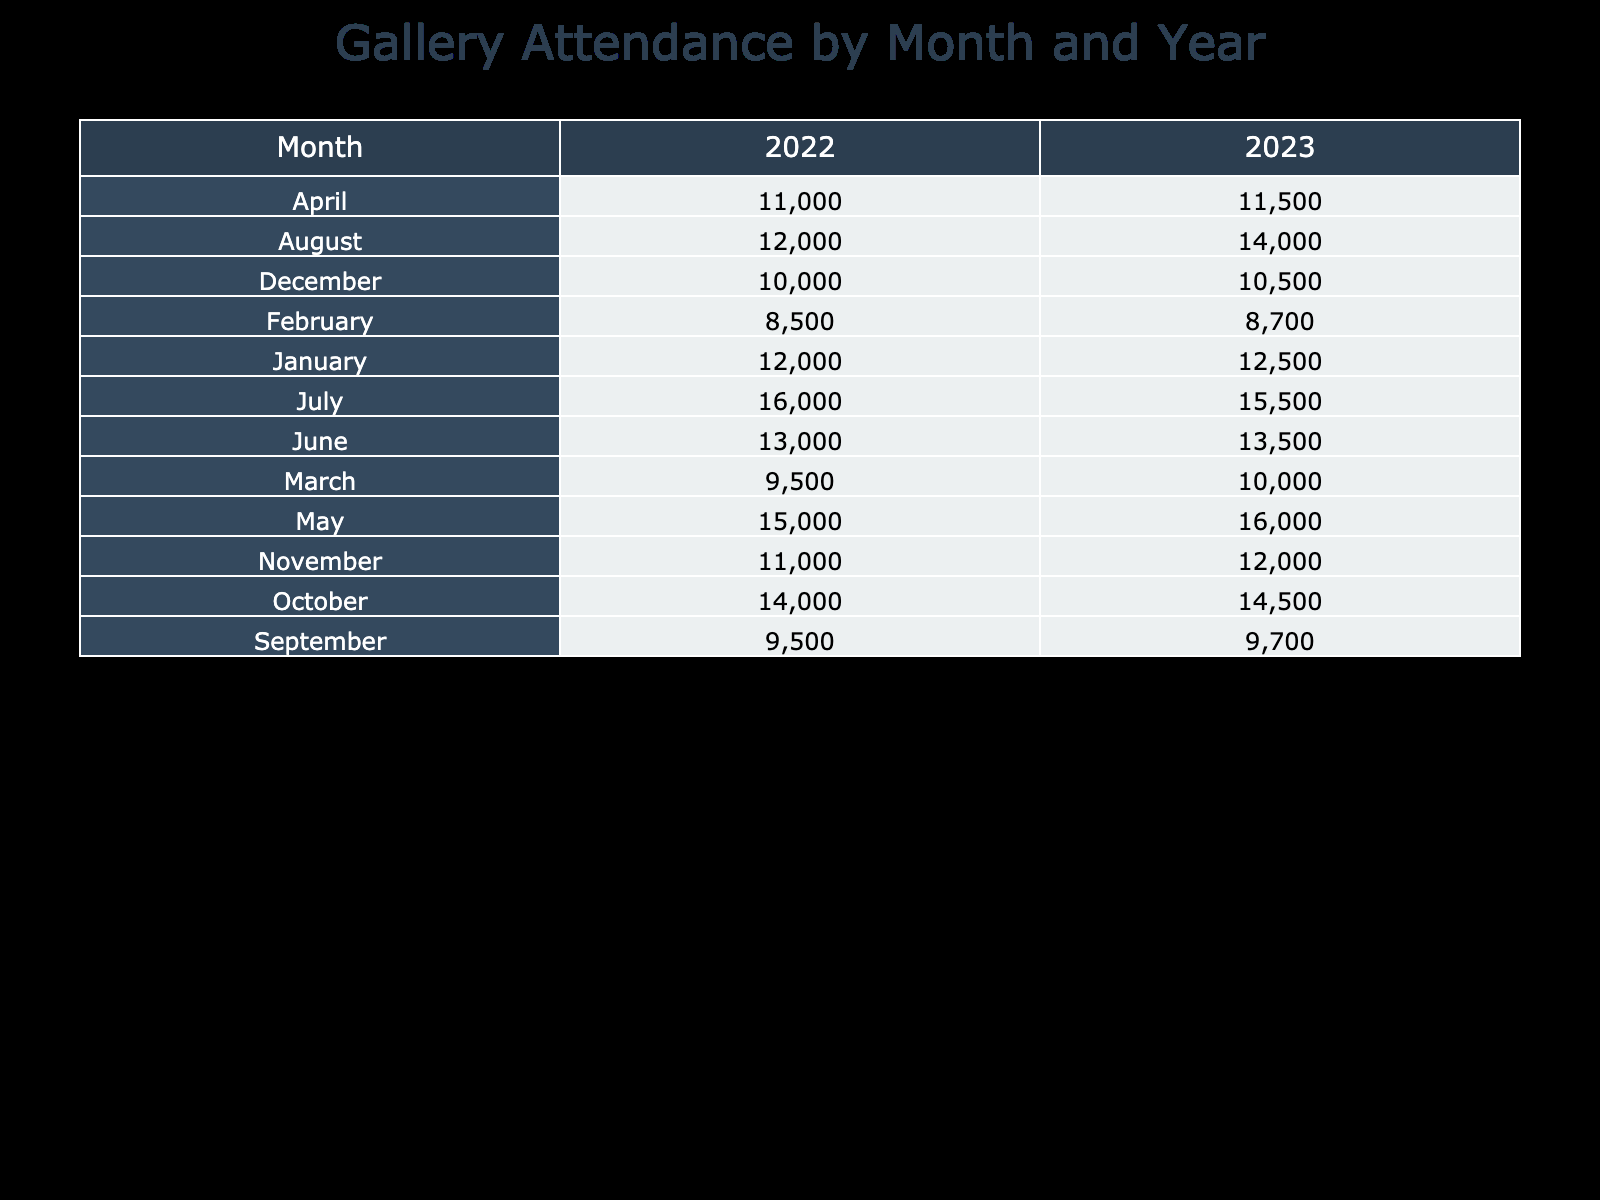What was the total attendance at The Whitney Museum in May 2022? In May 2022, the attendance for The Whitney Museum is listed as 15,000 in the table.
Answer: 15,000 What month in 2023 had the highest total attendance at the Tate Modern? In 2023, the Tate Modern has attendances of 15,500 in July. This is higher than all other months listed for this gallery in 2023.
Answer: July Which month had the lowest total attendance in 2022? By reviewing the total attendance figures for each month in 2022, February shows the lowest attendance at The Getty Center with 8,500.
Answer: February What was the average total attendance for all museums in December over the two years? The total attendance for December in 2022 is 10,000 and for 2023 is 10,500. To find the average, we add these together (10,000 + 10,500 = 20,500) and then divide by the number of entries (2), which gives us 10,250.
Answer: 10,250 Did the total attendance at The Museum of Modern Art increase from January 2022 to January 2023? In January 2022, the total attendance was 12,000, while in January 2023 it increased to 12,500. This indicates a positive change.
Answer: Yes What is the difference in total attendance between the British Museum in April 2022 and April 2023? The British Museum had an attendance of 11,000 in April 2022 and 11,500 in April 2023. To find the difference, we subtract 11,000 from 11,500, which results in a difference of 500.
Answer: 500 Which exhibition title in 2023 attracted the most visitors at The Art Institute of Chicago? In 2023, the exhibition titled "Masterpieces of the 20th Century" in December had an attendance of 10,500, which is the only figure provided for The Art Institute of Chicago in that year. Given the attendance data, this is the only exhibition's attendance we have to consider.
Answer: Masterpieces of the 20th Century What was the trend in ticket prices for the exhibitions at the Philadelphia Museum of Art from 2022 to 2023? The ticket price for the exhibitions at the Philadelphia Museum of Art for September in 2022 was 20, and in September 2023, it was 22. This denotes an increase in ticket prices over the year.
Answer: Increase What was the total attendance for all exhibitions at The Guggenheim in both years? For The Guggenheim, the attendance in August 2022 was 12,000 and in August 2023 it was 14,000. Adding these together gives a total of 26,000 for both years.
Answer: 26,000 